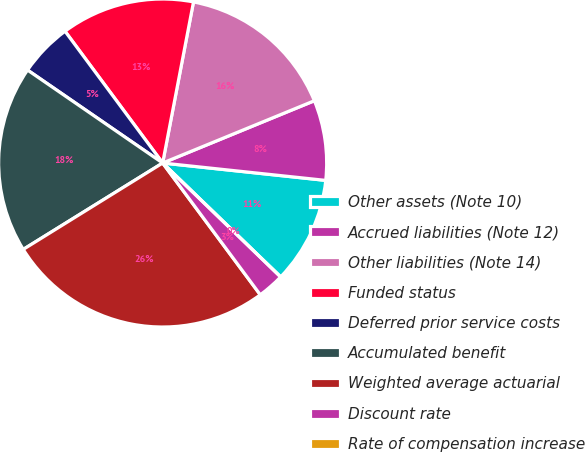Convert chart to OTSL. <chart><loc_0><loc_0><loc_500><loc_500><pie_chart><fcel>Other assets (Note 10)<fcel>Accrued liabilities (Note 12)<fcel>Other liabilities (Note 14)<fcel>Funded status<fcel>Deferred prior service costs<fcel>Accumulated benefit<fcel>Weighted average actuarial<fcel>Discount rate<fcel>Rate of compensation increase<nl><fcel>10.53%<fcel>7.89%<fcel>15.79%<fcel>13.16%<fcel>5.26%<fcel>18.42%<fcel>26.32%<fcel>2.63%<fcel>0.0%<nl></chart> 